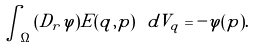Convert formula to latex. <formula><loc_0><loc_0><loc_500><loc_500>\int _ { \Omega } { ( D _ { r } \varphi ) E ( q , p ) } \ d V _ { q } = - \varphi ( p ) .</formula> 